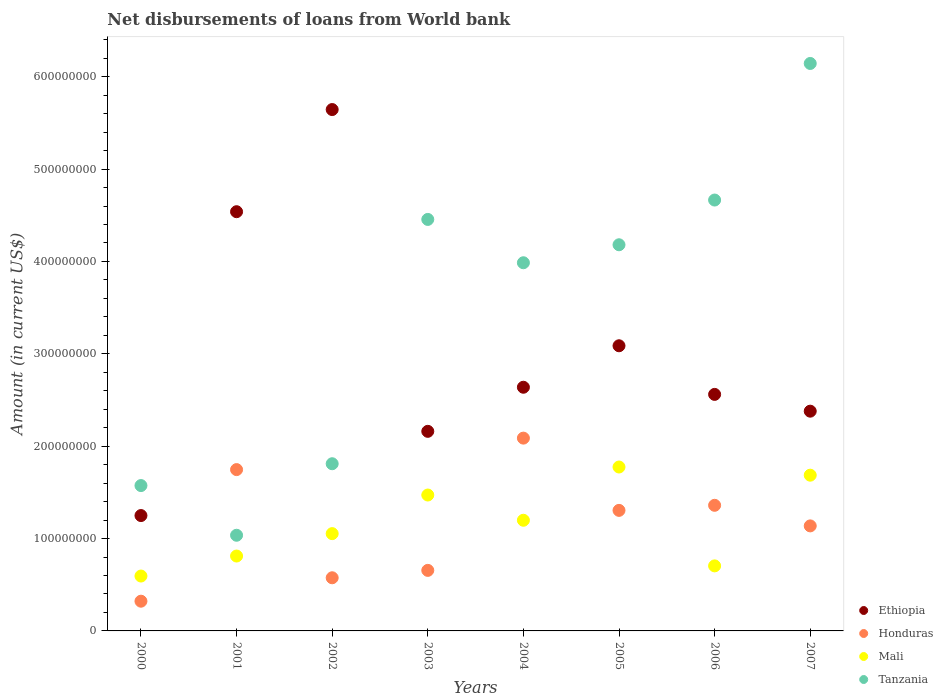How many different coloured dotlines are there?
Make the answer very short. 4. Is the number of dotlines equal to the number of legend labels?
Provide a short and direct response. Yes. What is the amount of loan disbursed from World Bank in Honduras in 2004?
Keep it short and to the point. 2.09e+08. Across all years, what is the maximum amount of loan disbursed from World Bank in Mali?
Provide a short and direct response. 1.77e+08. Across all years, what is the minimum amount of loan disbursed from World Bank in Ethiopia?
Keep it short and to the point. 1.25e+08. In which year was the amount of loan disbursed from World Bank in Honduras maximum?
Offer a terse response. 2004. In which year was the amount of loan disbursed from World Bank in Tanzania minimum?
Keep it short and to the point. 2001. What is the total amount of loan disbursed from World Bank in Honduras in the graph?
Offer a terse response. 9.19e+08. What is the difference between the amount of loan disbursed from World Bank in Tanzania in 2001 and that in 2006?
Provide a short and direct response. -3.63e+08. What is the difference between the amount of loan disbursed from World Bank in Tanzania in 2006 and the amount of loan disbursed from World Bank in Ethiopia in 2007?
Your answer should be compact. 2.29e+08. What is the average amount of loan disbursed from World Bank in Tanzania per year?
Provide a short and direct response. 3.48e+08. In the year 2003, what is the difference between the amount of loan disbursed from World Bank in Ethiopia and amount of loan disbursed from World Bank in Mali?
Provide a succinct answer. 6.89e+07. What is the ratio of the amount of loan disbursed from World Bank in Ethiopia in 2003 to that in 2006?
Offer a very short reply. 0.84. What is the difference between the highest and the second highest amount of loan disbursed from World Bank in Honduras?
Keep it short and to the point. 3.41e+07. What is the difference between the highest and the lowest amount of loan disbursed from World Bank in Honduras?
Your answer should be compact. 1.77e+08. In how many years, is the amount of loan disbursed from World Bank in Ethiopia greater than the average amount of loan disbursed from World Bank in Ethiopia taken over all years?
Your response must be concise. 3. Is the sum of the amount of loan disbursed from World Bank in Mali in 2006 and 2007 greater than the maximum amount of loan disbursed from World Bank in Tanzania across all years?
Offer a terse response. No. Is it the case that in every year, the sum of the amount of loan disbursed from World Bank in Tanzania and amount of loan disbursed from World Bank in Honduras  is greater than the sum of amount of loan disbursed from World Bank in Mali and amount of loan disbursed from World Bank in Ethiopia?
Provide a succinct answer. No. Is the amount of loan disbursed from World Bank in Honduras strictly less than the amount of loan disbursed from World Bank in Ethiopia over the years?
Ensure brevity in your answer.  Yes. How many years are there in the graph?
Your answer should be very brief. 8. What is the difference between two consecutive major ticks on the Y-axis?
Give a very brief answer. 1.00e+08. Are the values on the major ticks of Y-axis written in scientific E-notation?
Your response must be concise. No. Does the graph contain any zero values?
Make the answer very short. No. Does the graph contain grids?
Provide a short and direct response. No. How are the legend labels stacked?
Keep it short and to the point. Vertical. What is the title of the graph?
Offer a terse response. Net disbursements of loans from World bank. What is the label or title of the X-axis?
Ensure brevity in your answer.  Years. What is the label or title of the Y-axis?
Give a very brief answer. Amount (in current US$). What is the Amount (in current US$) in Ethiopia in 2000?
Make the answer very short. 1.25e+08. What is the Amount (in current US$) in Honduras in 2000?
Give a very brief answer. 3.22e+07. What is the Amount (in current US$) of Mali in 2000?
Keep it short and to the point. 5.94e+07. What is the Amount (in current US$) of Tanzania in 2000?
Make the answer very short. 1.57e+08. What is the Amount (in current US$) in Ethiopia in 2001?
Keep it short and to the point. 4.54e+08. What is the Amount (in current US$) in Honduras in 2001?
Your answer should be very brief. 1.75e+08. What is the Amount (in current US$) of Mali in 2001?
Make the answer very short. 8.11e+07. What is the Amount (in current US$) of Tanzania in 2001?
Provide a short and direct response. 1.04e+08. What is the Amount (in current US$) in Ethiopia in 2002?
Make the answer very short. 5.64e+08. What is the Amount (in current US$) of Honduras in 2002?
Provide a succinct answer. 5.75e+07. What is the Amount (in current US$) of Mali in 2002?
Your answer should be very brief. 1.05e+08. What is the Amount (in current US$) in Tanzania in 2002?
Your answer should be very brief. 1.81e+08. What is the Amount (in current US$) in Ethiopia in 2003?
Offer a very short reply. 2.16e+08. What is the Amount (in current US$) of Honduras in 2003?
Offer a very short reply. 6.55e+07. What is the Amount (in current US$) of Mali in 2003?
Your answer should be compact. 1.47e+08. What is the Amount (in current US$) in Tanzania in 2003?
Your response must be concise. 4.46e+08. What is the Amount (in current US$) of Ethiopia in 2004?
Make the answer very short. 2.64e+08. What is the Amount (in current US$) in Honduras in 2004?
Offer a very short reply. 2.09e+08. What is the Amount (in current US$) of Mali in 2004?
Make the answer very short. 1.20e+08. What is the Amount (in current US$) of Tanzania in 2004?
Provide a succinct answer. 3.99e+08. What is the Amount (in current US$) of Ethiopia in 2005?
Give a very brief answer. 3.09e+08. What is the Amount (in current US$) in Honduras in 2005?
Offer a very short reply. 1.31e+08. What is the Amount (in current US$) in Mali in 2005?
Your answer should be very brief. 1.77e+08. What is the Amount (in current US$) of Tanzania in 2005?
Your answer should be compact. 4.18e+08. What is the Amount (in current US$) of Ethiopia in 2006?
Provide a short and direct response. 2.56e+08. What is the Amount (in current US$) in Honduras in 2006?
Provide a succinct answer. 1.36e+08. What is the Amount (in current US$) in Mali in 2006?
Provide a succinct answer. 7.04e+07. What is the Amount (in current US$) in Tanzania in 2006?
Your answer should be very brief. 4.67e+08. What is the Amount (in current US$) of Ethiopia in 2007?
Keep it short and to the point. 2.38e+08. What is the Amount (in current US$) of Honduras in 2007?
Offer a terse response. 1.14e+08. What is the Amount (in current US$) of Mali in 2007?
Offer a terse response. 1.69e+08. What is the Amount (in current US$) in Tanzania in 2007?
Provide a short and direct response. 6.14e+08. Across all years, what is the maximum Amount (in current US$) in Ethiopia?
Make the answer very short. 5.64e+08. Across all years, what is the maximum Amount (in current US$) in Honduras?
Your answer should be compact. 2.09e+08. Across all years, what is the maximum Amount (in current US$) of Mali?
Your answer should be very brief. 1.77e+08. Across all years, what is the maximum Amount (in current US$) in Tanzania?
Your response must be concise. 6.14e+08. Across all years, what is the minimum Amount (in current US$) in Ethiopia?
Provide a succinct answer. 1.25e+08. Across all years, what is the minimum Amount (in current US$) of Honduras?
Your answer should be very brief. 3.22e+07. Across all years, what is the minimum Amount (in current US$) of Mali?
Your response must be concise. 5.94e+07. Across all years, what is the minimum Amount (in current US$) in Tanzania?
Ensure brevity in your answer.  1.04e+08. What is the total Amount (in current US$) in Ethiopia in the graph?
Offer a very short reply. 2.43e+09. What is the total Amount (in current US$) in Honduras in the graph?
Offer a very short reply. 9.19e+08. What is the total Amount (in current US$) of Mali in the graph?
Your answer should be very brief. 9.29e+08. What is the total Amount (in current US$) in Tanzania in the graph?
Give a very brief answer. 2.79e+09. What is the difference between the Amount (in current US$) of Ethiopia in 2000 and that in 2001?
Your answer should be very brief. -3.29e+08. What is the difference between the Amount (in current US$) of Honduras in 2000 and that in 2001?
Offer a very short reply. -1.42e+08. What is the difference between the Amount (in current US$) in Mali in 2000 and that in 2001?
Offer a terse response. -2.17e+07. What is the difference between the Amount (in current US$) of Tanzania in 2000 and that in 2001?
Provide a succinct answer. 5.38e+07. What is the difference between the Amount (in current US$) in Ethiopia in 2000 and that in 2002?
Provide a short and direct response. -4.40e+08. What is the difference between the Amount (in current US$) in Honduras in 2000 and that in 2002?
Offer a terse response. -2.54e+07. What is the difference between the Amount (in current US$) of Mali in 2000 and that in 2002?
Provide a succinct answer. -4.59e+07. What is the difference between the Amount (in current US$) of Tanzania in 2000 and that in 2002?
Offer a very short reply. -2.36e+07. What is the difference between the Amount (in current US$) in Ethiopia in 2000 and that in 2003?
Keep it short and to the point. -9.12e+07. What is the difference between the Amount (in current US$) in Honduras in 2000 and that in 2003?
Provide a succinct answer. -3.34e+07. What is the difference between the Amount (in current US$) of Mali in 2000 and that in 2003?
Your answer should be very brief. -8.77e+07. What is the difference between the Amount (in current US$) of Tanzania in 2000 and that in 2003?
Provide a succinct answer. -2.88e+08. What is the difference between the Amount (in current US$) of Ethiopia in 2000 and that in 2004?
Ensure brevity in your answer.  -1.39e+08. What is the difference between the Amount (in current US$) of Honduras in 2000 and that in 2004?
Offer a very short reply. -1.77e+08. What is the difference between the Amount (in current US$) of Mali in 2000 and that in 2004?
Ensure brevity in your answer.  -6.04e+07. What is the difference between the Amount (in current US$) of Tanzania in 2000 and that in 2004?
Make the answer very short. -2.41e+08. What is the difference between the Amount (in current US$) in Ethiopia in 2000 and that in 2005?
Your response must be concise. -1.84e+08. What is the difference between the Amount (in current US$) of Honduras in 2000 and that in 2005?
Your answer should be compact. -9.83e+07. What is the difference between the Amount (in current US$) in Mali in 2000 and that in 2005?
Your answer should be compact. -1.18e+08. What is the difference between the Amount (in current US$) of Tanzania in 2000 and that in 2005?
Keep it short and to the point. -2.61e+08. What is the difference between the Amount (in current US$) of Ethiopia in 2000 and that in 2006?
Provide a short and direct response. -1.31e+08. What is the difference between the Amount (in current US$) of Honduras in 2000 and that in 2006?
Provide a short and direct response. -1.04e+08. What is the difference between the Amount (in current US$) in Mali in 2000 and that in 2006?
Offer a very short reply. -1.10e+07. What is the difference between the Amount (in current US$) in Tanzania in 2000 and that in 2006?
Make the answer very short. -3.09e+08. What is the difference between the Amount (in current US$) of Ethiopia in 2000 and that in 2007?
Offer a very short reply. -1.13e+08. What is the difference between the Amount (in current US$) of Honduras in 2000 and that in 2007?
Ensure brevity in your answer.  -8.15e+07. What is the difference between the Amount (in current US$) of Mali in 2000 and that in 2007?
Give a very brief answer. -1.09e+08. What is the difference between the Amount (in current US$) of Tanzania in 2000 and that in 2007?
Make the answer very short. -4.57e+08. What is the difference between the Amount (in current US$) in Ethiopia in 2001 and that in 2002?
Provide a short and direct response. -1.11e+08. What is the difference between the Amount (in current US$) in Honduras in 2001 and that in 2002?
Ensure brevity in your answer.  1.17e+08. What is the difference between the Amount (in current US$) of Mali in 2001 and that in 2002?
Your response must be concise. -2.43e+07. What is the difference between the Amount (in current US$) of Tanzania in 2001 and that in 2002?
Offer a terse response. -7.74e+07. What is the difference between the Amount (in current US$) of Ethiopia in 2001 and that in 2003?
Your answer should be compact. 2.38e+08. What is the difference between the Amount (in current US$) of Honduras in 2001 and that in 2003?
Your answer should be compact. 1.09e+08. What is the difference between the Amount (in current US$) of Mali in 2001 and that in 2003?
Offer a terse response. -6.61e+07. What is the difference between the Amount (in current US$) in Tanzania in 2001 and that in 2003?
Give a very brief answer. -3.42e+08. What is the difference between the Amount (in current US$) of Ethiopia in 2001 and that in 2004?
Your answer should be compact. 1.90e+08. What is the difference between the Amount (in current US$) of Honduras in 2001 and that in 2004?
Offer a very short reply. -3.41e+07. What is the difference between the Amount (in current US$) in Mali in 2001 and that in 2004?
Your answer should be very brief. -3.87e+07. What is the difference between the Amount (in current US$) of Tanzania in 2001 and that in 2004?
Offer a very short reply. -2.95e+08. What is the difference between the Amount (in current US$) in Ethiopia in 2001 and that in 2005?
Offer a very short reply. 1.45e+08. What is the difference between the Amount (in current US$) in Honduras in 2001 and that in 2005?
Ensure brevity in your answer.  4.41e+07. What is the difference between the Amount (in current US$) of Mali in 2001 and that in 2005?
Provide a short and direct response. -9.64e+07. What is the difference between the Amount (in current US$) in Tanzania in 2001 and that in 2005?
Offer a very short reply. -3.15e+08. What is the difference between the Amount (in current US$) in Ethiopia in 2001 and that in 2006?
Offer a very short reply. 1.98e+08. What is the difference between the Amount (in current US$) of Honduras in 2001 and that in 2006?
Offer a terse response. 3.87e+07. What is the difference between the Amount (in current US$) in Mali in 2001 and that in 2006?
Provide a succinct answer. 1.07e+07. What is the difference between the Amount (in current US$) in Tanzania in 2001 and that in 2006?
Keep it short and to the point. -3.63e+08. What is the difference between the Amount (in current US$) of Ethiopia in 2001 and that in 2007?
Give a very brief answer. 2.16e+08. What is the difference between the Amount (in current US$) in Honduras in 2001 and that in 2007?
Offer a very short reply. 6.09e+07. What is the difference between the Amount (in current US$) in Mali in 2001 and that in 2007?
Offer a terse response. -8.75e+07. What is the difference between the Amount (in current US$) of Tanzania in 2001 and that in 2007?
Offer a terse response. -5.11e+08. What is the difference between the Amount (in current US$) of Ethiopia in 2002 and that in 2003?
Your answer should be compact. 3.48e+08. What is the difference between the Amount (in current US$) of Honduras in 2002 and that in 2003?
Your response must be concise. -8.01e+06. What is the difference between the Amount (in current US$) of Mali in 2002 and that in 2003?
Ensure brevity in your answer.  -4.18e+07. What is the difference between the Amount (in current US$) in Tanzania in 2002 and that in 2003?
Offer a very short reply. -2.65e+08. What is the difference between the Amount (in current US$) of Ethiopia in 2002 and that in 2004?
Give a very brief answer. 3.01e+08. What is the difference between the Amount (in current US$) of Honduras in 2002 and that in 2004?
Make the answer very short. -1.51e+08. What is the difference between the Amount (in current US$) of Mali in 2002 and that in 2004?
Your answer should be very brief. -1.45e+07. What is the difference between the Amount (in current US$) of Tanzania in 2002 and that in 2004?
Offer a terse response. -2.18e+08. What is the difference between the Amount (in current US$) of Ethiopia in 2002 and that in 2005?
Ensure brevity in your answer.  2.56e+08. What is the difference between the Amount (in current US$) of Honduras in 2002 and that in 2005?
Your answer should be compact. -7.30e+07. What is the difference between the Amount (in current US$) in Mali in 2002 and that in 2005?
Make the answer very short. -7.21e+07. What is the difference between the Amount (in current US$) in Tanzania in 2002 and that in 2005?
Your answer should be compact. -2.37e+08. What is the difference between the Amount (in current US$) of Ethiopia in 2002 and that in 2006?
Ensure brevity in your answer.  3.08e+08. What is the difference between the Amount (in current US$) of Honduras in 2002 and that in 2006?
Provide a short and direct response. -7.85e+07. What is the difference between the Amount (in current US$) in Mali in 2002 and that in 2006?
Your answer should be very brief. 3.49e+07. What is the difference between the Amount (in current US$) of Tanzania in 2002 and that in 2006?
Your answer should be very brief. -2.85e+08. What is the difference between the Amount (in current US$) of Ethiopia in 2002 and that in 2007?
Give a very brief answer. 3.27e+08. What is the difference between the Amount (in current US$) of Honduras in 2002 and that in 2007?
Ensure brevity in your answer.  -5.62e+07. What is the difference between the Amount (in current US$) in Mali in 2002 and that in 2007?
Your answer should be compact. -6.33e+07. What is the difference between the Amount (in current US$) in Tanzania in 2002 and that in 2007?
Provide a short and direct response. -4.33e+08. What is the difference between the Amount (in current US$) in Ethiopia in 2003 and that in 2004?
Provide a succinct answer. -4.77e+07. What is the difference between the Amount (in current US$) of Honduras in 2003 and that in 2004?
Make the answer very short. -1.43e+08. What is the difference between the Amount (in current US$) in Mali in 2003 and that in 2004?
Provide a short and direct response. 2.73e+07. What is the difference between the Amount (in current US$) in Tanzania in 2003 and that in 2004?
Your response must be concise. 4.69e+07. What is the difference between the Amount (in current US$) in Ethiopia in 2003 and that in 2005?
Offer a very short reply. -9.26e+07. What is the difference between the Amount (in current US$) of Honduras in 2003 and that in 2005?
Your answer should be very brief. -6.50e+07. What is the difference between the Amount (in current US$) in Mali in 2003 and that in 2005?
Provide a succinct answer. -3.03e+07. What is the difference between the Amount (in current US$) in Tanzania in 2003 and that in 2005?
Offer a very short reply. 2.74e+07. What is the difference between the Amount (in current US$) in Ethiopia in 2003 and that in 2006?
Your answer should be compact. -4.00e+07. What is the difference between the Amount (in current US$) in Honduras in 2003 and that in 2006?
Provide a succinct answer. -7.04e+07. What is the difference between the Amount (in current US$) in Mali in 2003 and that in 2006?
Provide a short and direct response. 7.67e+07. What is the difference between the Amount (in current US$) of Tanzania in 2003 and that in 2006?
Ensure brevity in your answer.  -2.10e+07. What is the difference between the Amount (in current US$) in Ethiopia in 2003 and that in 2007?
Give a very brief answer. -2.18e+07. What is the difference between the Amount (in current US$) of Honduras in 2003 and that in 2007?
Your response must be concise. -4.82e+07. What is the difference between the Amount (in current US$) of Mali in 2003 and that in 2007?
Ensure brevity in your answer.  -2.15e+07. What is the difference between the Amount (in current US$) in Tanzania in 2003 and that in 2007?
Give a very brief answer. -1.69e+08. What is the difference between the Amount (in current US$) in Ethiopia in 2004 and that in 2005?
Your response must be concise. -4.49e+07. What is the difference between the Amount (in current US$) in Honduras in 2004 and that in 2005?
Provide a succinct answer. 7.82e+07. What is the difference between the Amount (in current US$) in Mali in 2004 and that in 2005?
Your response must be concise. -5.76e+07. What is the difference between the Amount (in current US$) of Tanzania in 2004 and that in 2005?
Give a very brief answer. -1.95e+07. What is the difference between the Amount (in current US$) in Ethiopia in 2004 and that in 2006?
Offer a very short reply. 7.74e+06. What is the difference between the Amount (in current US$) of Honduras in 2004 and that in 2006?
Make the answer very short. 7.27e+07. What is the difference between the Amount (in current US$) of Mali in 2004 and that in 2006?
Offer a very short reply. 4.94e+07. What is the difference between the Amount (in current US$) in Tanzania in 2004 and that in 2006?
Give a very brief answer. -6.79e+07. What is the difference between the Amount (in current US$) in Ethiopia in 2004 and that in 2007?
Keep it short and to the point. 2.59e+07. What is the difference between the Amount (in current US$) in Honduras in 2004 and that in 2007?
Keep it short and to the point. 9.50e+07. What is the difference between the Amount (in current US$) of Mali in 2004 and that in 2007?
Provide a succinct answer. -4.88e+07. What is the difference between the Amount (in current US$) of Tanzania in 2004 and that in 2007?
Keep it short and to the point. -2.16e+08. What is the difference between the Amount (in current US$) of Ethiopia in 2005 and that in 2006?
Provide a short and direct response. 5.26e+07. What is the difference between the Amount (in current US$) in Honduras in 2005 and that in 2006?
Your answer should be very brief. -5.49e+06. What is the difference between the Amount (in current US$) of Mali in 2005 and that in 2006?
Keep it short and to the point. 1.07e+08. What is the difference between the Amount (in current US$) in Tanzania in 2005 and that in 2006?
Your answer should be compact. -4.84e+07. What is the difference between the Amount (in current US$) in Ethiopia in 2005 and that in 2007?
Offer a terse response. 7.08e+07. What is the difference between the Amount (in current US$) in Honduras in 2005 and that in 2007?
Make the answer very short. 1.68e+07. What is the difference between the Amount (in current US$) in Mali in 2005 and that in 2007?
Your response must be concise. 8.85e+06. What is the difference between the Amount (in current US$) of Tanzania in 2005 and that in 2007?
Your response must be concise. -1.96e+08. What is the difference between the Amount (in current US$) of Ethiopia in 2006 and that in 2007?
Offer a terse response. 1.82e+07. What is the difference between the Amount (in current US$) in Honduras in 2006 and that in 2007?
Give a very brief answer. 2.23e+07. What is the difference between the Amount (in current US$) in Mali in 2006 and that in 2007?
Provide a succinct answer. -9.82e+07. What is the difference between the Amount (in current US$) of Tanzania in 2006 and that in 2007?
Your answer should be compact. -1.48e+08. What is the difference between the Amount (in current US$) in Ethiopia in 2000 and the Amount (in current US$) in Honduras in 2001?
Your answer should be compact. -4.98e+07. What is the difference between the Amount (in current US$) in Ethiopia in 2000 and the Amount (in current US$) in Mali in 2001?
Your response must be concise. 4.38e+07. What is the difference between the Amount (in current US$) of Ethiopia in 2000 and the Amount (in current US$) of Tanzania in 2001?
Make the answer very short. 2.13e+07. What is the difference between the Amount (in current US$) of Honduras in 2000 and the Amount (in current US$) of Mali in 2001?
Your response must be concise. -4.89e+07. What is the difference between the Amount (in current US$) of Honduras in 2000 and the Amount (in current US$) of Tanzania in 2001?
Your answer should be compact. -7.14e+07. What is the difference between the Amount (in current US$) in Mali in 2000 and the Amount (in current US$) in Tanzania in 2001?
Keep it short and to the point. -4.42e+07. What is the difference between the Amount (in current US$) of Ethiopia in 2000 and the Amount (in current US$) of Honduras in 2002?
Your answer should be very brief. 6.74e+07. What is the difference between the Amount (in current US$) in Ethiopia in 2000 and the Amount (in current US$) in Mali in 2002?
Your response must be concise. 1.96e+07. What is the difference between the Amount (in current US$) of Ethiopia in 2000 and the Amount (in current US$) of Tanzania in 2002?
Your response must be concise. -5.61e+07. What is the difference between the Amount (in current US$) in Honduras in 2000 and the Amount (in current US$) in Mali in 2002?
Offer a terse response. -7.32e+07. What is the difference between the Amount (in current US$) of Honduras in 2000 and the Amount (in current US$) of Tanzania in 2002?
Provide a short and direct response. -1.49e+08. What is the difference between the Amount (in current US$) in Mali in 2000 and the Amount (in current US$) in Tanzania in 2002?
Offer a very short reply. -1.22e+08. What is the difference between the Amount (in current US$) of Ethiopia in 2000 and the Amount (in current US$) of Honduras in 2003?
Keep it short and to the point. 5.94e+07. What is the difference between the Amount (in current US$) in Ethiopia in 2000 and the Amount (in current US$) in Mali in 2003?
Your response must be concise. -2.22e+07. What is the difference between the Amount (in current US$) of Ethiopia in 2000 and the Amount (in current US$) of Tanzania in 2003?
Your response must be concise. -3.21e+08. What is the difference between the Amount (in current US$) of Honduras in 2000 and the Amount (in current US$) of Mali in 2003?
Offer a very short reply. -1.15e+08. What is the difference between the Amount (in current US$) of Honduras in 2000 and the Amount (in current US$) of Tanzania in 2003?
Offer a terse response. -4.13e+08. What is the difference between the Amount (in current US$) in Mali in 2000 and the Amount (in current US$) in Tanzania in 2003?
Make the answer very short. -3.86e+08. What is the difference between the Amount (in current US$) in Ethiopia in 2000 and the Amount (in current US$) in Honduras in 2004?
Keep it short and to the point. -8.38e+07. What is the difference between the Amount (in current US$) of Ethiopia in 2000 and the Amount (in current US$) of Mali in 2004?
Your answer should be very brief. 5.08e+06. What is the difference between the Amount (in current US$) of Ethiopia in 2000 and the Amount (in current US$) of Tanzania in 2004?
Offer a terse response. -2.74e+08. What is the difference between the Amount (in current US$) of Honduras in 2000 and the Amount (in current US$) of Mali in 2004?
Your response must be concise. -8.76e+07. What is the difference between the Amount (in current US$) in Honduras in 2000 and the Amount (in current US$) in Tanzania in 2004?
Make the answer very short. -3.66e+08. What is the difference between the Amount (in current US$) in Mali in 2000 and the Amount (in current US$) in Tanzania in 2004?
Your response must be concise. -3.39e+08. What is the difference between the Amount (in current US$) in Ethiopia in 2000 and the Amount (in current US$) in Honduras in 2005?
Give a very brief answer. -5.61e+06. What is the difference between the Amount (in current US$) of Ethiopia in 2000 and the Amount (in current US$) of Mali in 2005?
Provide a short and direct response. -5.26e+07. What is the difference between the Amount (in current US$) of Ethiopia in 2000 and the Amount (in current US$) of Tanzania in 2005?
Offer a terse response. -2.93e+08. What is the difference between the Amount (in current US$) in Honduras in 2000 and the Amount (in current US$) in Mali in 2005?
Offer a very short reply. -1.45e+08. What is the difference between the Amount (in current US$) of Honduras in 2000 and the Amount (in current US$) of Tanzania in 2005?
Offer a very short reply. -3.86e+08. What is the difference between the Amount (in current US$) of Mali in 2000 and the Amount (in current US$) of Tanzania in 2005?
Give a very brief answer. -3.59e+08. What is the difference between the Amount (in current US$) of Ethiopia in 2000 and the Amount (in current US$) of Honduras in 2006?
Your answer should be very brief. -1.11e+07. What is the difference between the Amount (in current US$) in Ethiopia in 2000 and the Amount (in current US$) in Mali in 2006?
Ensure brevity in your answer.  5.45e+07. What is the difference between the Amount (in current US$) in Ethiopia in 2000 and the Amount (in current US$) in Tanzania in 2006?
Your answer should be very brief. -3.42e+08. What is the difference between the Amount (in current US$) in Honduras in 2000 and the Amount (in current US$) in Mali in 2006?
Make the answer very short. -3.82e+07. What is the difference between the Amount (in current US$) of Honduras in 2000 and the Amount (in current US$) of Tanzania in 2006?
Offer a very short reply. -4.34e+08. What is the difference between the Amount (in current US$) of Mali in 2000 and the Amount (in current US$) of Tanzania in 2006?
Offer a very short reply. -4.07e+08. What is the difference between the Amount (in current US$) of Ethiopia in 2000 and the Amount (in current US$) of Honduras in 2007?
Make the answer very short. 1.12e+07. What is the difference between the Amount (in current US$) of Ethiopia in 2000 and the Amount (in current US$) of Mali in 2007?
Provide a short and direct response. -4.37e+07. What is the difference between the Amount (in current US$) of Ethiopia in 2000 and the Amount (in current US$) of Tanzania in 2007?
Provide a succinct answer. -4.89e+08. What is the difference between the Amount (in current US$) of Honduras in 2000 and the Amount (in current US$) of Mali in 2007?
Offer a very short reply. -1.36e+08. What is the difference between the Amount (in current US$) of Honduras in 2000 and the Amount (in current US$) of Tanzania in 2007?
Your answer should be compact. -5.82e+08. What is the difference between the Amount (in current US$) of Mali in 2000 and the Amount (in current US$) of Tanzania in 2007?
Offer a terse response. -5.55e+08. What is the difference between the Amount (in current US$) in Ethiopia in 2001 and the Amount (in current US$) in Honduras in 2002?
Ensure brevity in your answer.  3.96e+08. What is the difference between the Amount (in current US$) in Ethiopia in 2001 and the Amount (in current US$) in Mali in 2002?
Give a very brief answer. 3.49e+08. What is the difference between the Amount (in current US$) of Ethiopia in 2001 and the Amount (in current US$) of Tanzania in 2002?
Your response must be concise. 2.73e+08. What is the difference between the Amount (in current US$) in Honduras in 2001 and the Amount (in current US$) in Mali in 2002?
Keep it short and to the point. 6.93e+07. What is the difference between the Amount (in current US$) of Honduras in 2001 and the Amount (in current US$) of Tanzania in 2002?
Offer a very short reply. -6.36e+06. What is the difference between the Amount (in current US$) of Mali in 2001 and the Amount (in current US$) of Tanzania in 2002?
Keep it short and to the point. -9.99e+07. What is the difference between the Amount (in current US$) of Ethiopia in 2001 and the Amount (in current US$) of Honduras in 2003?
Provide a succinct answer. 3.88e+08. What is the difference between the Amount (in current US$) of Ethiopia in 2001 and the Amount (in current US$) of Mali in 2003?
Give a very brief answer. 3.07e+08. What is the difference between the Amount (in current US$) of Ethiopia in 2001 and the Amount (in current US$) of Tanzania in 2003?
Your response must be concise. 8.36e+06. What is the difference between the Amount (in current US$) of Honduras in 2001 and the Amount (in current US$) of Mali in 2003?
Your response must be concise. 2.75e+07. What is the difference between the Amount (in current US$) of Honduras in 2001 and the Amount (in current US$) of Tanzania in 2003?
Offer a very short reply. -2.71e+08. What is the difference between the Amount (in current US$) in Mali in 2001 and the Amount (in current US$) in Tanzania in 2003?
Offer a terse response. -3.64e+08. What is the difference between the Amount (in current US$) in Ethiopia in 2001 and the Amount (in current US$) in Honduras in 2004?
Your answer should be very brief. 2.45e+08. What is the difference between the Amount (in current US$) in Ethiopia in 2001 and the Amount (in current US$) in Mali in 2004?
Ensure brevity in your answer.  3.34e+08. What is the difference between the Amount (in current US$) in Ethiopia in 2001 and the Amount (in current US$) in Tanzania in 2004?
Ensure brevity in your answer.  5.53e+07. What is the difference between the Amount (in current US$) in Honduras in 2001 and the Amount (in current US$) in Mali in 2004?
Your answer should be compact. 5.48e+07. What is the difference between the Amount (in current US$) of Honduras in 2001 and the Amount (in current US$) of Tanzania in 2004?
Keep it short and to the point. -2.24e+08. What is the difference between the Amount (in current US$) of Mali in 2001 and the Amount (in current US$) of Tanzania in 2004?
Keep it short and to the point. -3.18e+08. What is the difference between the Amount (in current US$) of Ethiopia in 2001 and the Amount (in current US$) of Honduras in 2005?
Make the answer very short. 3.23e+08. What is the difference between the Amount (in current US$) of Ethiopia in 2001 and the Amount (in current US$) of Mali in 2005?
Offer a very short reply. 2.76e+08. What is the difference between the Amount (in current US$) in Ethiopia in 2001 and the Amount (in current US$) in Tanzania in 2005?
Ensure brevity in your answer.  3.58e+07. What is the difference between the Amount (in current US$) of Honduras in 2001 and the Amount (in current US$) of Mali in 2005?
Offer a very short reply. -2.80e+06. What is the difference between the Amount (in current US$) of Honduras in 2001 and the Amount (in current US$) of Tanzania in 2005?
Keep it short and to the point. -2.43e+08. What is the difference between the Amount (in current US$) of Mali in 2001 and the Amount (in current US$) of Tanzania in 2005?
Provide a short and direct response. -3.37e+08. What is the difference between the Amount (in current US$) in Ethiopia in 2001 and the Amount (in current US$) in Honduras in 2006?
Keep it short and to the point. 3.18e+08. What is the difference between the Amount (in current US$) of Ethiopia in 2001 and the Amount (in current US$) of Mali in 2006?
Provide a short and direct response. 3.83e+08. What is the difference between the Amount (in current US$) in Ethiopia in 2001 and the Amount (in current US$) in Tanzania in 2006?
Offer a terse response. -1.26e+07. What is the difference between the Amount (in current US$) in Honduras in 2001 and the Amount (in current US$) in Mali in 2006?
Your response must be concise. 1.04e+08. What is the difference between the Amount (in current US$) in Honduras in 2001 and the Amount (in current US$) in Tanzania in 2006?
Give a very brief answer. -2.92e+08. What is the difference between the Amount (in current US$) in Mali in 2001 and the Amount (in current US$) in Tanzania in 2006?
Ensure brevity in your answer.  -3.85e+08. What is the difference between the Amount (in current US$) in Ethiopia in 2001 and the Amount (in current US$) in Honduras in 2007?
Keep it short and to the point. 3.40e+08. What is the difference between the Amount (in current US$) in Ethiopia in 2001 and the Amount (in current US$) in Mali in 2007?
Keep it short and to the point. 2.85e+08. What is the difference between the Amount (in current US$) of Ethiopia in 2001 and the Amount (in current US$) of Tanzania in 2007?
Provide a short and direct response. -1.60e+08. What is the difference between the Amount (in current US$) of Honduras in 2001 and the Amount (in current US$) of Mali in 2007?
Provide a succinct answer. 6.04e+06. What is the difference between the Amount (in current US$) in Honduras in 2001 and the Amount (in current US$) in Tanzania in 2007?
Your answer should be very brief. -4.40e+08. What is the difference between the Amount (in current US$) of Mali in 2001 and the Amount (in current US$) of Tanzania in 2007?
Keep it short and to the point. -5.33e+08. What is the difference between the Amount (in current US$) in Ethiopia in 2002 and the Amount (in current US$) in Honduras in 2003?
Keep it short and to the point. 4.99e+08. What is the difference between the Amount (in current US$) in Ethiopia in 2002 and the Amount (in current US$) in Mali in 2003?
Offer a terse response. 4.17e+08. What is the difference between the Amount (in current US$) in Ethiopia in 2002 and the Amount (in current US$) in Tanzania in 2003?
Make the answer very short. 1.19e+08. What is the difference between the Amount (in current US$) of Honduras in 2002 and the Amount (in current US$) of Mali in 2003?
Ensure brevity in your answer.  -8.96e+07. What is the difference between the Amount (in current US$) in Honduras in 2002 and the Amount (in current US$) in Tanzania in 2003?
Keep it short and to the point. -3.88e+08. What is the difference between the Amount (in current US$) in Mali in 2002 and the Amount (in current US$) in Tanzania in 2003?
Your answer should be very brief. -3.40e+08. What is the difference between the Amount (in current US$) of Ethiopia in 2002 and the Amount (in current US$) of Honduras in 2004?
Provide a short and direct response. 3.56e+08. What is the difference between the Amount (in current US$) of Ethiopia in 2002 and the Amount (in current US$) of Mali in 2004?
Give a very brief answer. 4.45e+08. What is the difference between the Amount (in current US$) of Ethiopia in 2002 and the Amount (in current US$) of Tanzania in 2004?
Provide a short and direct response. 1.66e+08. What is the difference between the Amount (in current US$) of Honduras in 2002 and the Amount (in current US$) of Mali in 2004?
Keep it short and to the point. -6.23e+07. What is the difference between the Amount (in current US$) in Honduras in 2002 and the Amount (in current US$) in Tanzania in 2004?
Your response must be concise. -3.41e+08. What is the difference between the Amount (in current US$) of Mali in 2002 and the Amount (in current US$) of Tanzania in 2004?
Ensure brevity in your answer.  -2.93e+08. What is the difference between the Amount (in current US$) of Ethiopia in 2002 and the Amount (in current US$) of Honduras in 2005?
Offer a very short reply. 4.34e+08. What is the difference between the Amount (in current US$) of Ethiopia in 2002 and the Amount (in current US$) of Mali in 2005?
Your answer should be compact. 3.87e+08. What is the difference between the Amount (in current US$) of Ethiopia in 2002 and the Amount (in current US$) of Tanzania in 2005?
Offer a very short reply. 1.46e+08. What is the difference between the Amount (in current US$) in Honduras in 2002 and the Amount (in current US$) in Mali in 2005?
Ensure brevity in your answer.  -1.20e+08. What is the difference between the Amount (in current US$) in Honduras in 2002 and the Amount (in current US$) in Tanzania in 2005?
Keep it short and to the point. -3.61e+08. What is the difference between the Amount (in current US$) in Mali in 2002 and the Amount (in current US$) in Tanzania in 2005?
Provide a succinct answer. -3.13e+08. What is the difference between the Amount (in current US$) in Ethiopia in 2002 and the Amount (in current US$) in Honduras in 2006?
Offer a very short reply. 4.28e+08. What is the difference between the Amount (in current US$) of Ethiopia in 2002 and the Amount (in current US$) of Mali in 2006?
Your answer should be very brief. 4.94e+08. What is the difference between the Amount (in current US$) in Ethiopia in 2002 and the Amount (in current US$) in Tanzania in 2006?
Keep it short and to the point. 9.80e+07. What is the difference between the Amount (in current US$) of Honduras in 2002 and the Amount (in current US$) of Mali in 2006?
Ensure brevity in your answer.  -1.29e+07. What is the difference between the Amount (in current US$) of Honduras in 2002 and the Amount (in current US$) of Tanzania in 2006?
Keep it short and to the point. -4.09e+08. What is the difference between the Amount (in current US$) of Mali in 2002 and the Amount (in current US$) of Tanzania in 2006?
Your answer should be compact. -3.61e+08. What is the difference between the Amount (in current US$) of Ethiopia in 2002 and the Amount (in current US$) of Honduras in 2007?
Keep it short and to the point. 4.51e+08. What is the difference between the Amount (in current US$) in Ethiopia in 2002 and the Amount (in current US$) in Mali in 2007?
Provide a short and direct response. 3.96e+08. What is the difference between the Amount (in current US$) of Ethiopia in 2002 and the Amount (in current US$) of Tanzania in 2007?
Ensure brevity in your answer.  -4.99e+07. What is the difference between the Amount (in current US$) of Honduras in 2002 and the Amount (in current US$) of Mali in 2007?
Your answer should be very brief. -1.11e+08. What is the difference between the Amount (in current US$) in Honduras in 2002 and the Amount (in current US$) in Tanzania in 2007?
Ensure brevity in your answer.  -5.57e+08. What is the difference between the Amount (in current US$) of Mali in 2002 and the Amount (in current US$) of Tanzania in 2007?
Give a very brief answer. -5.09e+08. What is the difference between the Amount (in current US$) of Ethiopia in 2003 and the Amount (in current US$) of Honduras in 2004?
Your response must be concise. 7.35e+06. What is the difference between the Amount (in current US$) in Ethiopia in 2003 and the Amount (in current US$) in Mali in 2004?
Your answer should be compact. 9.63e+07. What is the difference between the Amount (in current US$) in Ethiopia in 2003 and the Amount (in current US$) in Tanzania in 2004?
Offer a terse response. -1.83e+08. What is the difference between the Amount (in current US$) in Honduras in 2003 and the Amount (in current US$) in Mali in 2004?
Your response must be concise. -5.43e+07. What is the difference between the Amount (in current US$) of Honduras in 2003 and the Amount (in current US$) of Tanzania in 2004?
Provide a succinct answer. -3.33e+08. What is the difference between the Amount (in current US$) in Mali in 2003 and the Amount (in current US$) in Tanzania in 2004?
Offer a very short reply. -2.51e+08. What is the difference between the Amount (in current US$) of Ethiopia in 2003 and the Amount (in current US$) of Honduras in 2005?
Your answer should be very brief. 8.56e+07. What is the difference between the Amount (in current US$) in Ethiopia in 2003 and the Amount (in current US$) in Mali in 2005?
Offer a very short reply. 3.86e+07. What is the difference between the Amount (in current US$) in Ethiopia in 2003 and the Amount (in current US$) in Tanzania in 2005?
Provide a succinct answer. -2.02e+08. What is the difference between the Amount (in current US$) in Honduras in 2003 and the Amount (in current US$) in Mali in 2005?
Your answer should be compact. -1.12e+08. What is the difference between the Amount (in current US$) in Honduras in 2003 and the Amount (in current US$) in Tanzania in 2005?
Provide a short and direct response. -3.53e+08. What is the difference between the Amount (in current US$) of Mali in 2003 and the Amount (in current US$) of Tanzania in 2005?
Offer a very short reply. -2.71e+08. What is the difference between the Amount (in current US$) of Ethiopia in 2003 and the Amount (in current US$) of Honduras in 2006?
Ensure brevity in your answer.  8.01e+07. What is the difference between the Amount (in current US$) of Ethiopia in 2003 and the Amount (in current US$) of Mali in 2006?
Your answer should be compact. 1.46e+08. What is the difference between the Amount (in current US$) of Ethiopia in 2003 and the Amount (in current US$) of Tanzania in 2006?
Offer a terse response. -2.50e+08. What is the difference between the Amount (in current US$) of Honduras in 2003 and the Amount (in current US$) of Mali in 2006?
Keep it short and to the point. -4.87e+06. What is the difference between the Amount (in current US$) of Honduras in 2003 and the Amount (in current US$) of Tanzania in 2006?
Your answer should be very brief. -4.01e+08. What is the difference between the Amount (in current US$) in Mali in 2003 and the Amount (in current US$) in Tanzania in 2006?
Your answer should be very brief. -3.19e+08. What is the difference between the Amount (in current US$) of Ethiopia in 2003 and the Amount (in current US$) of Honduras in 2007?
Make the answer very short. 1.02e+08. What is the difference between the Amount (in current US$) of Ethiopia in 2003 and the Amount (in current US$) of Mali in 2007?
Keep it short and to the point. 4.75e+07. What is the difference between the Amount (in current US$) in Ethiopia in 2003 and the Amount (in current US$) in Tanzania in 2007?
Make the answer very short. -3.98e+08. What is the difference between the Amount (in current US$) of Honduras in 2003 and the Amount (in current US$) of Mali in 2007?
Make the answer very short. -1.03e+08. What is the difference between the Amount (in current US$) in Honduras in 2003 and the Amount (in current US$) in Tanzania in 2007?
Your answer should be compact. -5.49e+08. What is the difference between the Amount (in current US$) in Mali in 2003 and the Amount (in current US$) in Tanzania in 2007?
Give a very brief answer. -4.67e+08. What is the difference between the Amount (in current US$) of Ethiopia in 2004 and the Amount (in current US$) of Honduras in 2005?
Your response must be concise. 1.33e+08. What is the difference between the Amount (in current US$) in Ethiopia in 2004 and the Amount (in current US$) in Mali in 2005?
Make the answer very short. 8.64e+07. What is the difference between the Amount (in current US$) of Ethiopia in 2004 and the Amount (in current US$) of Tanzania in 2005?
Ensure brevity in your answer.  -1.54e+08. What is the difference between the Amount (in current US$) of Honduras in 2004 and the Amount (in current US$) of Mali in 2005?
Your answer should be very brief. 3.13e+07. What is the difference between the Amount (in current US$) in Honduras in 2004 and the Amount (in current US$) in Tanzania in 2005?
Offer a terse response. -2.09e+08. What is the difference between the Amount (in current US$) in Mali in 2004 and the Amount (in current US$) in Tanzania in 2005?
Provide a short and direct response. -2.98e+08. What is the difference between the Amount (in current US$) in Ethiopia in 2004 and the Amount (in current US$) in Honduras in 2006?
Keep it short and to the point. 1.28e+08. What is the difference between the Amount (in current US$) in Ethiopia in 2004 and the Amount (in current US$) in Mali in 2006?
Offer a terse response. 1.93e+08. What is the difference between the Amount (in current US$) of Ethiopia in 2004 and the Amount (in current US$) of Tanzania in 2006?
Your answer should be compact. -2.03e+08. What is the difference between the Amount (in current US$) in Honduras in 2004 and the Amount (in current US$) in Mali in 2006?
Make the answer very short. 1.38e+08. What is the difference between the Amount (in current US$) in Honduras in 2004 and the Amount (in current US$) in Tanzania in 2006?
Keep it short and to the point. -2.58e+08. What is the difference between the Amount (in current US$) of Mali in 2004 and the Amount (in current US$) of Tanzania in 2006?
Provide a succinct answer. -3.47e+08. What is the difference between the Amount (in current US$) in Ethiopia in 2004 and the Amount (in current US$) in Honduras in 2007?
Offer a terse response. 1.50e+08. What is the difference between the Amount (in current US$) in Ethiopia in 2004 and the Amount (in current US$) in Mali in 2007?
Provide a succinct answer. 9.52e+07. What is the difference between the Amount (in current US$) in Ethiopia in 2004 and the Amount (in current US$) in Tanzania in 2007?
Offer a terse response. -3.51e+08. What is the difference between the Amount (in current US$) in Honduras in 2004 and the Amount (in current US$) in Mali in 2007?
Your answer should be compact. 4.01e+07. What is the difference between the Amount (in current US$) in Honduras in 2004 and the Amount (in current US$) in Tanzania in 2007?
Offer a very short reply. -4.06e+08. What is the difference between the Amount (in current US$) in Mali in 2004 and the Amount (in current US$) in Tanzania in 2007?
Your answer should be compact. -4.95e+08. What is the difference between the Amount (in current US$) of Ethiopia in 2005 and the Amount (in current US$) of Honduras in 2006?
Offer a terse response. 1.73e+08. What is the difference between the Amount (in current US$) of Ethiopia in 2005 and the Amount (in current US$) of Mali in 2006?
Keep it short and to the point. 2.38e+08. What is the difference between the Amount (in current US$) of Ethiopia in 2005 and the Amount (in current US$) of Tanzania in 2006?
Your answer should be very brief. -1.58e+08. What is the difference between the Amount (in current US$) of Honduras in 2005 and the Amount (in current US$) of Mali in 2006?
Ensure brevity in your answer.  6.01e+07. What is the difference between the Amount (in current US$) of Honduras in 2005 and the Amount (in current US$) of Tanzania in 2006?
Make the answer very short. -3.36e+08. What is the difference between the Amount (in current US$) in Mali in 2005 and the Amount (in current US$) in Tanzania in 2006?
Provide a succinct answer. -2.89e+08. What is the difference between the Amount (in current US$) of Ethiopia in 2005 and the Amount (in current US$) of Honduras in 2007?
Your answer should be very brief. 1.95e+08. What is the difference between the Amount (in current US$) in Ethiopia in 2005 and the Amount (in current US$) in Mali in 2007?
Keep it short and to the point. 1.40e+08. What is the difference between the Amount (in current US$) in Ethiopia in 2005 and the Amount (in current US$) in Tanzania in 2007?
Provide a succinct answer. -3.06e+08. What is the difference between the Amount (in current US$) of Honduras in 2005 and the Amount (in current US$) of Mali in 2007?
Your response must be concise. -3.81e+07. What is the difference between the Amount (in current US$) in Honduras in 2005 and the Amount (in current US$) in Tanzania in 2007?
Ensure brevity in your answer.  -4.84e+08. What is the difference between the Amount (in current US$) in Mali in 2005 and the Amount (in current US$) in Tanzania in 2007?
Your answer should be very brief. -4.37e+08. What is the difference between the Amount (in current US$) in Ethiopia in 2006 and the Amount (in current US$) in Honduras in 2007?
Offer a terse response. 1.42e+08. What is the difference between the Amount (in current US$) of Ethiopia in 2006 and the Amount (in current US$) of Mali in 2007?
Give a very brief answer. 8.75e+07. What is the difference between the Amount (in current US$) of Ethiopia in 2006 and the Amount (in current US$) of Tanzania in 2007?
Keep it short and to the point. -3.58e+08. What is the difference between the Amount (in current US$) of Honduras in 2006 and the Amount (in current US$) of Mali in 2007?
Make the answer very short. -3.26e+07. What is the difference between the Amount (in current US$) in Honduras in 2006 and the Amount (in current US$) in Tanzania in 2007?
Your answer should be very brief. -4.78e+08. What is the difference between the Amount (in current US$) of Mali in 2006 and the Amount (in current US$) of Tanzania in 2007?
Your answer should be compact. -5.44e+08. What is the average Amount (in current US$) in Ethiopia per year?
Your answer should be very brief. 3.03e+08. What is the average Amount (in current US$) of Honduras per year?
Give a very brief answer. 1.15e+08. What is the average Amount (in current US$) of Mali per year?
Give a very brief answer. 1.16e+08. What is the average Amount (in current US$) of Tanzania per year?
Give a very brief answer. 3.48e+08. In the year 2000, what is the difference between the Amount (in current US$) of Ethiopia and Amount (in current US$) of Honduras?
Offer a very short reply. 9.27e+07. In the year 2000, what is the difference between the Amount (in current US$) of Ethiopia and Amount (in current US$) of Mali?
Make the answer very short. 6.55e+07. In the year 2000, what is the difference between the Amount (in current US$) in Ethiopia and Amount (in current US$) in Tanzania?
Offer a terse response. -3.25e+07. In the year 2000, what is the difference between the Amount (in current US$) of Honduras and Amount (in current US$) of Mali?
Your answer should be compact. -2.72e+07. In the year 2000, what is the difference between the Amount (in current US$) of Honduras and Amount (in current US$) of Tanzania?
Your answer should be compact. -1.25e+08. In the year 2000, what is the difference between the Amount (in current US$) of Mali and Amount (in current US$) of Tanzania?
Your answer should be compact. -9.80e+07. In the year 2001, what is the difference between the Amount (in current US$) of Ethiopia and Amount (in current US$) of Honduras?
Keep it short and to the point. 2.79e+08. In the year 2001, what is the difference between the Amount (in current US$) of Ethiopia and Amount (in current US$) of Mali?
Your response must be concise. 3.73e+08. In the year 2001, what is the difference between the Amount (in current US$) of Ethiopia and Amount (in current US$) of Tanzania?
Make the answer very short. 3.50e+08. In the year 2001, what is the difference between the Amount (in current US$) in Honduras and Amount (in current US$) in Mali?
Your answer should be very brief. 9.36e+07. In the year 2001, what is the difference between the Amount (in current US$) of Honduras and Amount (in current US$) of Tanzania?
Make the answer very short. 7.11e+07. In the year 2001, what is the difference between the Amount (in current US$) of Mali and Amount (in current US$) of Tanzania?
Provide a short and direct response. -2.25e+07. In the year 2002, what is the difference between the Amount (in current US$) in Ethiopia and Amount (in current US$) in Honduras?
Make the answer very short. 5.07e+08. In the year 2002, what is the difference between the Amount (in current US$) of Ethiopia and Amount (in current US$) of Mali?
Your answer should be very brief. 4.59e+08. In the year 2002, what is the difference between the Amount (in current US$) of Ethiopia and Amount (in current US$) of Tanzania?
Provide a short and direct response. 3.83e+08. In the year 2002, what is the difference between the Amount (in current US$) in Honduras and Amount (in current US$) in Mali?
Ensure brevity in your answer.  -4.78e+07. In the year 2002, what is the difference between the Amount (in current US$) of Honduras and Amount (in current US$) of Tanzania?
Your answer should be very brief. -1.23e+08. In the year 2002, what is the difference between the Amount (in current US$) in Mali and Amount (in current US$) in Tanzania?
Give a very brief answer. -7.57e+07. In the year 2003, what is the difference between the Amount (in current US$) in Ethiopia and Amount (in current US$) in Honduras?
Provide a succinct answer. 1.51e+08. In the year 2003, what is the difference between the Amount (in current US$) in Ethiopia and Amount (in current US$) in Mali?
Offer a very short reply. 6.89e+07. In the year 2003, what is the difference between the Amount (in current US$) of Ethiopia and Amount (in current US$) of Tanzania?
Your answer should be compact. -2.29e+08. In the year 2003, what is the difference between the Amount (in current US$) of Honduras and Amount (in current US$) of Mali?
Your answer should be very brief. -8.16e+07. In the year 2003, what is the difference between the Amount (in current US$) in Honduras and Amount (in current US$) in Tanzania?
Your response must be concise. -3.80e+08. In the year 2003, what is the difference between the Amount (in current US$) of Mali and Amount (in current US$) of Tanzania?
Offer a terse response. -2.98e+08. In the year 2004, what is the difference between the Amount (in current US$) of Ethiopia and Amount (in current US$) of Honduras?
Your answer should be very brief. 5.51e+07. In the year 2004, what is the difference between the Amount (in current US$) of Ethiopia and Amount (in current US$) of Mali?
Your response must be concise. 1.44e+08. In the year 2004, what is the difference between the Amount (in current US$) of Ethiopia and Amount (in current US$) of Tanzania?
Make the answer very short. -1.35e+08. In the year 2004, what is the difference between the Amount (in current US$) in Honduras and Amount (in current US$) in Mali?
Make the answer very short. 8.89e+07. In the year 2004, what is the difference between the Amount (in current US$) in Honduras and Amount (in current US$) in Tanzania?
Offer a terse response. -1.90e+08. In the year 2004, what is the difference between the Amount (in current US$) in Mali and Amount (in current US$) in Tanzania?
Your response must be concise. -2.79e+08. In the year 2005, what is the difference between the Amount (in current US$) in Ethiopia and Amount (in current US$) in Honduras?
Give a very brief answer. 1.78e+08. In the year 2005, what is the difference between the Amount (in current US$) in Ethiopia and Amount (in current US$) in Mali?
Ensure brevity in your answer.  1.31e+08. In the year 2005, what is the difference between the Amount (in current US$) in Ethiopia and Amount (in current US$) in Tanzania?
Offer a very short reply. -1.09e+08. In the year 2005, what is the difference between the Amount (in current US$) in Honduras and Amount (in current US$) in Mali?
Your answer should be very brief. -4.70e+07. In the year 2005, what is the difference between the Amount (in current US$) of Honduras and Amount (in current US$) of Tanzania?
Ensure brevity in your answer.  -2.88e+08. In the year 2005, what is the difference between the Amount (in current US$) in Mali and Amount (in current US$) in Tanzania?
Keep it short and to the point. -2.41e+08. In the year 2006, what is the difference between the Amount (in current US$) in Ethiopia and Amount (in current US$) in Honduras?
Provide a succinct answer. 1.20e+08. In the year 2006, what is the difference between the Amount (in current US$) in Ethiopia and Amount (in current US$) in Mali?
Keep it short and to the point. 1.86e+08. In the year 2006, what is the difference between the Amount (in current US$) in Ethiopia and Amount (in current US$) in Tanzania?
Your response must be concise. -2.10e+08. In the year 2006, what is the difference between the Amount (in current US$) in Honduras and Amount (in current US$) in Mali?
Your answer should be compact. 6.56e+07. In the year 2006, what is the difference between the Amount (in current US$) in Honduras and Amount (in current US$) in Tanzania?
Make the answer very short. -3.31e+08. In the year 2006, what is the difference between the Amount (in current US$) of Mali and Amount (in current US$) of Tanzania?
Give a very brief answer. -3.96e+08. In the year 2007, what is the difference between the Amount (in current US$) in Ethiopia and Amount (in current US$) in Honduras?
Your answer should be very brief. 1.24e+08. In the year 2007, what is the difference between the Amount (in current US$) of Ethiopia and Amount (in current US$) of Mali?
Provide a succinct answer. 6.93e+07. In the year 2007, what is the difference between the Amount (in current US$) in Ethiopia and Amount (in current US$) in Tanzania?
Your answer should be compact. -3.76e+08. In the year 2007, what is the difference between the Amount (in current US$) of Honduras and Amount (in current US$) of Mali?
Your answer should be compact. -5.49e+07. In the year 2007, what is the difference between the Amount (in current US$) of Honduras and Amount (in current US$) of Tanzania?
Offer a very short reply. -5.01e+08. In the year 2007, what is the difference between the Amount (in current US$) of Mali and Amount (in current US$) of Tanzania?
Provide a short and direct response. -4.46e+08. What is the ratio of the Amount (in current US$) in Ethiopia in 2000 to that in 2001?
Make the answer very short. 0.28. What is the ratio of the Amount (in current US$) of Honduras in 2000 to that in 2001?
Ensure brevity in your answer.  0.18. What is the ratio of the Amount (in current US$) of Mali in 2000 to that in 2001?
Provide a succinct answer. 0.73. What is the ratio of the Amount (in current US$) of Tanzania in 2000 to that in 2001?
Ensure brevity in your answer.  1.52. What is the ratio of the Amount (in current US$) in Ethiopia in 2000 to that in 2002?
Keep it short and to the point. 0.22. What is the ratio of the Amount (in current US$) in Honduras in 2000 to that in 2002?
Give a very brief answer. 0.56. What is the ratio of the Amount (in current US$) in Mali in 2000 to that in 2002?
Keep it short and to the point. 0.56. What is the ratio of the Amount (in current US$) of Tanzania in 2000 to that in 2002?
Offer a terse response. 0.87. What is the ratio of the Amount (in current US$) of Ethiopia in 2000 to that in 2003?
Give a very brief answer. 0.58. What is the ratio of the Amount (in current US$) of Honduras in 2000 to that in 2003?
Provide a succinct answer. 0.49. What is the ratio of the Amount (in current US$) in Mali in 2000 to that in 2003?
Provide a short and direct response. 0.4. What is the ratio of the Amount (in current US$) of Tanzania in 2000 to that in 2003?
Your answer should be compact. 0.35. What is the ratio of the Amount (in current US$) of Ethiopia in 2000 to that in 2004?
Give a very brief answer. 0.47. What is the ratio of the Amount (in current US$) of Honduras in 2000 to that in 2004?
Offer a terse response. 0.15. What is the ratio of the Amount (in current US$) in Mali in 2000 to that in 2004?
Your answer should be compact. 0.5. What is the ratio of the Amount (in current US$) of Tanzania in 2000 to that in 2004?
Offer a terse response. 0.39. What is the ratio of the Amount (in current US$) in Ethiopia in 2000 to that in 2005?
Offer a very short reply. 0.4. What is the ratio of the Amount (in current US$) of Honduras in 2000 to that in 2005?
Give a very brief answer. 0.25. What is the ratio of the Amount (in current US$) of Mali in 2000 to that in 2005?
Your answer should be compact. 0.33. What is the ratio of the Amount (in current US$) of Tanzania in 2000 to that in 2005?
Your answer should be compact. 0.38. What is the ratio of the Amount (in current US$) of Ethiopia in 2000 to that in 2006?
Ensure brevity in your answer.  0.49. What is the ratio of the Amount (in current US$) of Honduras in 2000 to that in 2006?
Provide a short and direct response. 0.24. What is the ratio of the Amount (in current US$) of Mali in 2000 to that in 2006?
Offer a terse response. 0.84. What is the ratio of the Amount (in current US$) of Tanzania in 2000 to that in 2006?
Offer a terse response. 0.34. What is the ratio of the Amount (in current US$) in Ethiopia in 2000 to that in 2007?
Offer a very short reply. 0.53. What is the ratio of the Amount (in current US$) of Honduras in 2000 to that in 2007?
Provide a succinct answer. 0.28. What is the ratio of the Amount (in current US$) of Mali in 2000 to that in 2007?
Offer a terse response. 0.35. What is the ratio of the Amount (in current US$) in Tanzania in 2000 to that in 2007?
Ensure brevity in your answer.  0.26. What is the ratio of the Amount (in current US$) in Ethiopia in 2001 to that in 2002?
Ensure brevity in your answer.  0.8. What is the ratio of the Amount (in current US$) in Honduras in 2001 to that in 2002?
Make the answer very short. 3.04. What is the ratio of the Amount (in current US$) in Mali in 2001 to that in 2002?
Your answer should be very brief. 0.77. What is the ratio of the Amount (in current US$) in Tanzania in 2001 to that in 2002?
Your response must be concise. 0.57. What is the ratio of the Amount (in current US$) in Ethiopia in 2001 to that in 2003?
Provide a succinct answer. 2.1. What is the ratio of the Amount (in current US$) of Honduras in 2001 to that in 2003?
Make the answer very short. 2.66. What is the ratio of the Amount (in current US$) of Mali in 2001 to that in 2003?
Provide a short and direct response. 0.55. What is the ratio of the Amount (in current US$) in Tanzania in 2001 to that in 2003?
Keep it short and to the point. 0.23. What is the ratio of the Amount (in current US$) in Ethiopia in 2001 to that in 2004?
Keep it short and to the point. 1.72. What is the ratio of the Amount (in current US$) of Honduras in 2001 to that in 2004?
Your answer should be compact. 0.84. What is the ratio of the Amount (in current US$) in Mali in 2001 to that in 2004?
Ensure brevity in your answer.  0.68. What is the ratio of the Amount (in current US$) in Tanzania in 2001 to that in 2004?
Your answer should be compact. 0.26. What is the ratio of the Amount (in current US$) of Ethiopia in 2001 to that in 2005?
Your response must be concise. 1.47. What is the ratio of the Amount (in current US$) in Honduras in 2001 to that in 2005?
Give a very brief answer. 1.34. What is the ratio of the Amount (in current US$) of Mali in 2001 to that in 2005?
Your answer should be very brief. 0.46. What is the ratio of the Amount (in current US$) of Tanzania in 2001 to that in 2005?
Keep it short and to the point. 0.25. What is the ratio of the Amount (in current US$) in Ethiopia in 2001 to that in 2006?
Give a very brief answer. 1.77. What is the ratio of the Amount (in current US$) in Honduras in 2001 to that in 2006?
Offer a terse response. 1.28. What is the ratio of the Amount (in current US$) of Mali in 2001 to that in 2006?
Provide a short and direct response. 1.15. What is the ratio of the Amount (in current US$) in Tanzania in 2001 to that in 2006?
Ensure brevity in your answer.  0.22. What is the ratio of the Amount (in current US$) in Ethiopia in 2001 to that in 2007?
Offer a terse response. 1.91. What is the ratio of the Amount (in current US$) of Honduras in 2001 to that in 2007?
Provide a succinct answer. 1.54. What is the ratio of the Amount (in current US$) of Mali in 2001 to that in 2007?
Offer a very short reply. 0.48. What is the ratio of the Amount (in current US$) of Tanzania in 2001 to that in 2007?
Give a very brief answer. 0.17. What is the ratio of the Amount (in current US$) in Ethiopia in 2002 to that in 2003?
Make the answer very short. 2.61. What is the ratio of the Amount (in current US$) in Honduras in 2002 to that in 2003?
Provide a succinct answer. 0.88. What is the ratio of the Amount (in current US$) of Mali in 2002 to that in 2003?
Your answer should be compact. 0.72. What is the ratio of the Amount (in current US$) of Tanzania in 2002 to that in 2003?
Give a very brief answer. 0.41. What is the ratio of the Amount (in current US$) in Ethiopia in 2002 to that in 2004?
Your answer should be very brief. 2.14. What is the ratio of the Amount (in current US$) of Honduras in 2002 to that in 2004?
Ensure brevity in your answer.  0.28. What is the ratio of the Amount (in current US$) of Mali in 2002 to that in 2004?
Your response must be concise. 0.88. What is the ratio of the Amount (in current US$) in Tanzania in 2002 to that in 2004?
Provide a succinct answer. 0.45. What is the ratio of the Amount (in current US$) in Ethiopia in 2002 to that in 2005?
Your answer should be compact. 1.83. What is the ratio of the Amount (in current US$) of Honduras in 2002 to that in 2005?
Give a very brief answer. 0.44. What is the ratio of the Amount (in current US$) in Mali in 2002 to that in 2005?
Offer a terse response. 0.59. What is the ratio of the Amount (in current US$) in Tanzania in 2002 to that in 2005?
Your response must be concise. 0.43. What is the ratio of the Amount (in current US$) in Ethiopia in 2002 to that in 2006?
Ensure brevity in your answer.  2.2. What is the ratio of the Amount (in current US$) of Honduras in 2002 to that in 2006?
Your answer should be compact. 0.42. What is the ratio of the Amount (in current US$) in Mali in 2002 to that in 2006?
Keep it short and to the point. 1.5. What is the ratio of the Amount (in current US$) of Tanzania in 2002 to that in 2006?
Ensure brevity in your answer.  0.39. What is the ratio of the Amount (in current US$) in Ethiopia in 2002 to that in 2007?
Ensure brevity in your answer.  2.37. What is the ratio of the Amount (in current US$) in Honduras in 2002 to that in 2007?
Provide a short and direct response. 0.51. What is the ratio of the Amount (in current US$) of Mali in 2002 to that in 2007?
Provide a succinct answer. 0.62. What is the ratio of the Amount (in current US$) of Tanzania in 2002 to that in 2007?
Keep it short and to the point. 0.29. What is the ratio of the Amount (in current US$) in Ethiopia in 2003 to that in 2004?
Your answer should be very brief. 0.82. What is the ratio of the Amount (in current US$) in Honduras in 2003 to that in 2004?
Your answer should be very brief. 0.31. What is the ratio of the Amount (in current US$) of Mali in 2003 to that in 2004?
Your response must be concise. 1.23. What is the ratio of the Amount (in current US$) in Tanzania in 2003 to that in 2004?
Offer a terse response. 1.12. What is the ratio of the Amount (in current US$) of Ethiopia in 2003 to that in 2005?
Your response must be concise. 0.7. What is the ratio of the Amount (in current US$) of Honduras in 2003 to that in 2005?
Provide a short and direct response. 0.5. What is the ratio of the Amount (in current US$) of Mali in 2003 to that in 2005?
Your response must be concise. 0.83. What is the ratio of the Amount (in current US$) in Tanzania in 2003 to that in 2005?
Offer a very short reply. 1.07. What is the ratio of the Amount (in current US$) of Ethiopia in 2003 to that in 2006?
Offer a terse response. 0.84. What is the ratio of the Amount (in current US$) in Honduras in 2003 to that in 2006?
Give a very brief answer. 0.48. What is the ratio of the Amount (in current US$) in Mali in 2003 to that in 2006?
Provide a short and direct response. 2.09. What is the ratio of the Amount (in current US$) of Tanzania in 2003 to that in 2006?
Offer a very short reply. 0.95. What is the ratio of the Amount (in current US$) in Ethiopia in 2003 to that in 2007?
Make the answer very short. 0.91. What is the ratio of the Amount (in current US$) of Honduras in 2003 to that in 2007?
Offer a very short reply. 0.58. What is the ratio of the Amount (in current US$) in Mali in 2003 to that in 2007?
Your answer should be compact. 0.87. What is the ratio of the Amount (in current US$) in Tanzania in 2003 to that in 2007?
Keep it short and to the point. 0.73. What is the ratio of the Amount (in current US$) in Ethiopia in 2004 to that in 2005?
Make the answer very short. 0.85. What is the ratio of the Amount (in current US$) of Honduras in 2004 to that in 2005?
Ensure brevity in your answer.  1.6. What is the ratio of the Amount (in current US$) of Mali in 2004 to that in 2005?
Your answer should be very brief. 0.68. What is the ratio of the Amount (in current US$) of Tanzania in 2004 to that in 2005?
Provide a short and direct response. 0.95. What is the ratio of the Amount (in current US$) in Ethiopia in 2004 to that in 2006?
Provide a succinct answer. 1.03. What is the ratio of the Amount (in current US$) of Honduras in 2004 to that in 2006?
Keep it short and to the point. 1.53. What is the ratio of the Amount (in current US$) in Mali in 2004 to that in 2006?
Provide a succinct answer. 1.7. What is the ratio of the Amount (in current US$) of Tanzania in 2004 to that in 2006?
Make the answer very short. 0.85. What is the ratio of the Amount (in current US$) of Ethiopia in 2004 to that in 2007?
Offer a very short reply. 1.11. What is the ratio of the Amount (in current US$) of Honduras in 2004 to that in 2007?
Keep it short and to the point. 1.84. What is the ratio of the Amount (in current US$) of Mali in 2004 to that in 2007?
Provide a succinct answer. 0.71. What is the ratio of the Amount (in current US$) of Tanzania in 2004 to that in 2007?
Provide a succinct answer. 0.65. What is the ratio of the Amount (in current US$) in Ethiopia in 2005 to that in 2006?
Your answer should be compact. 1.21. What is the ratio of the Amount (in current US$) in Honduras in 2005 to that in 2006?
Your answer should be compact. 0.96. What is the ratio of the Amount (in current US$) of Mali in 2005 to that in 2006?
Offer a terse response. 2.52. What is the ratio of the Amount (in current US$) of Tanzania in 2005 to that in 2006?
Your answer should be very brief. 0.9. What is the ratio of the Amount (in current US$) in Ethiopia in 2005 to that in 2007?
Offer a very short reply. 1.3. What is the ratio of the Amount (in current US$) of Honduras in 2005 to that in 2007?
Provide a succinct answer. 1.15. What is the ratio of the Amount (in current US$) in Mali in 2005 to that in 2007?
Offer a terse response. 1.05. What is the ratio of the Amount (in current US$) of Tanzania in 2005 to that in 2007?
Your response must be concise. 0.68. What is the ratio of the Amount (in current US$) of Ethiopia in 2006 to that in 2007?
Offer a very short reply. 1.08. What is the ratio of the Amount (in current US$) of Honduras in 2006 to that in 2007?
Your answer should be very brief. 1.2. What is the ratio of the Amount (in current US$) of Mali in 2006 to that in 2007?
Offer a very short reply. 0.42. What is the ratio of the Amount (in current US$) in Tanzania in 2006 to that in 2007?
Offer a terse response. 0.76. What is the difference between the highest and the second highest Amount (in current US$) in Ethiopia?
Provide a succinct answer. 1.11e+08. What is the difference between the highest and the second highest Amount (in current US$) in Honduras?
Keep it short and to the point. 3.41e+07. What is the difference between the highest and the second highest Amount (in current US$) in Mali?
Keep it short and to the point. 8.85e+06. What is the difference between the highest and the second highest Amount (in current US$) of Tanzania?
Provide a succinct answer. 1.48e+08. What is the difference between the highest and the lowest Amount (in current US$) of Ethiopia?
Your response must be concise. 4.40e+08. What is the difference between the highest and the lowest Amount (in current US$) in Honduras?
Your response must be concise. 1.77e+08. What is the difference between the highest and the lowest Amount (in current US$) in Mali?
Keep it short and to the point. 1.18e+08. What is the difference between the highest and the lowest Amount (in current US$) of Tanzania?
Make the answer very short. 5.11e+08. 